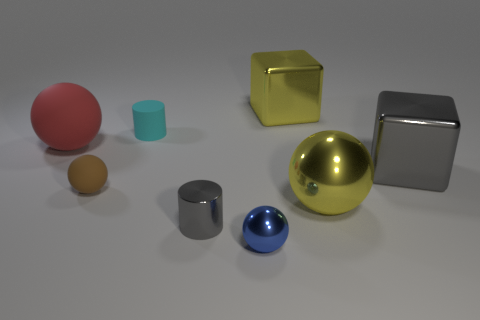Add 2 blocks. How many objects exist? 10 Subtract all blocks. How many objects are left? 6 Add 5 small matte objects. How many small matte objects are left? 7 Add 7 small cyan matte objects. How many small cyan matte objects exist? 8 Subtract 0 purple balls. How many objects are left? 8 Subtract all yellow metallic spheres. Subtract all big cubes. How many objects are left? 5 